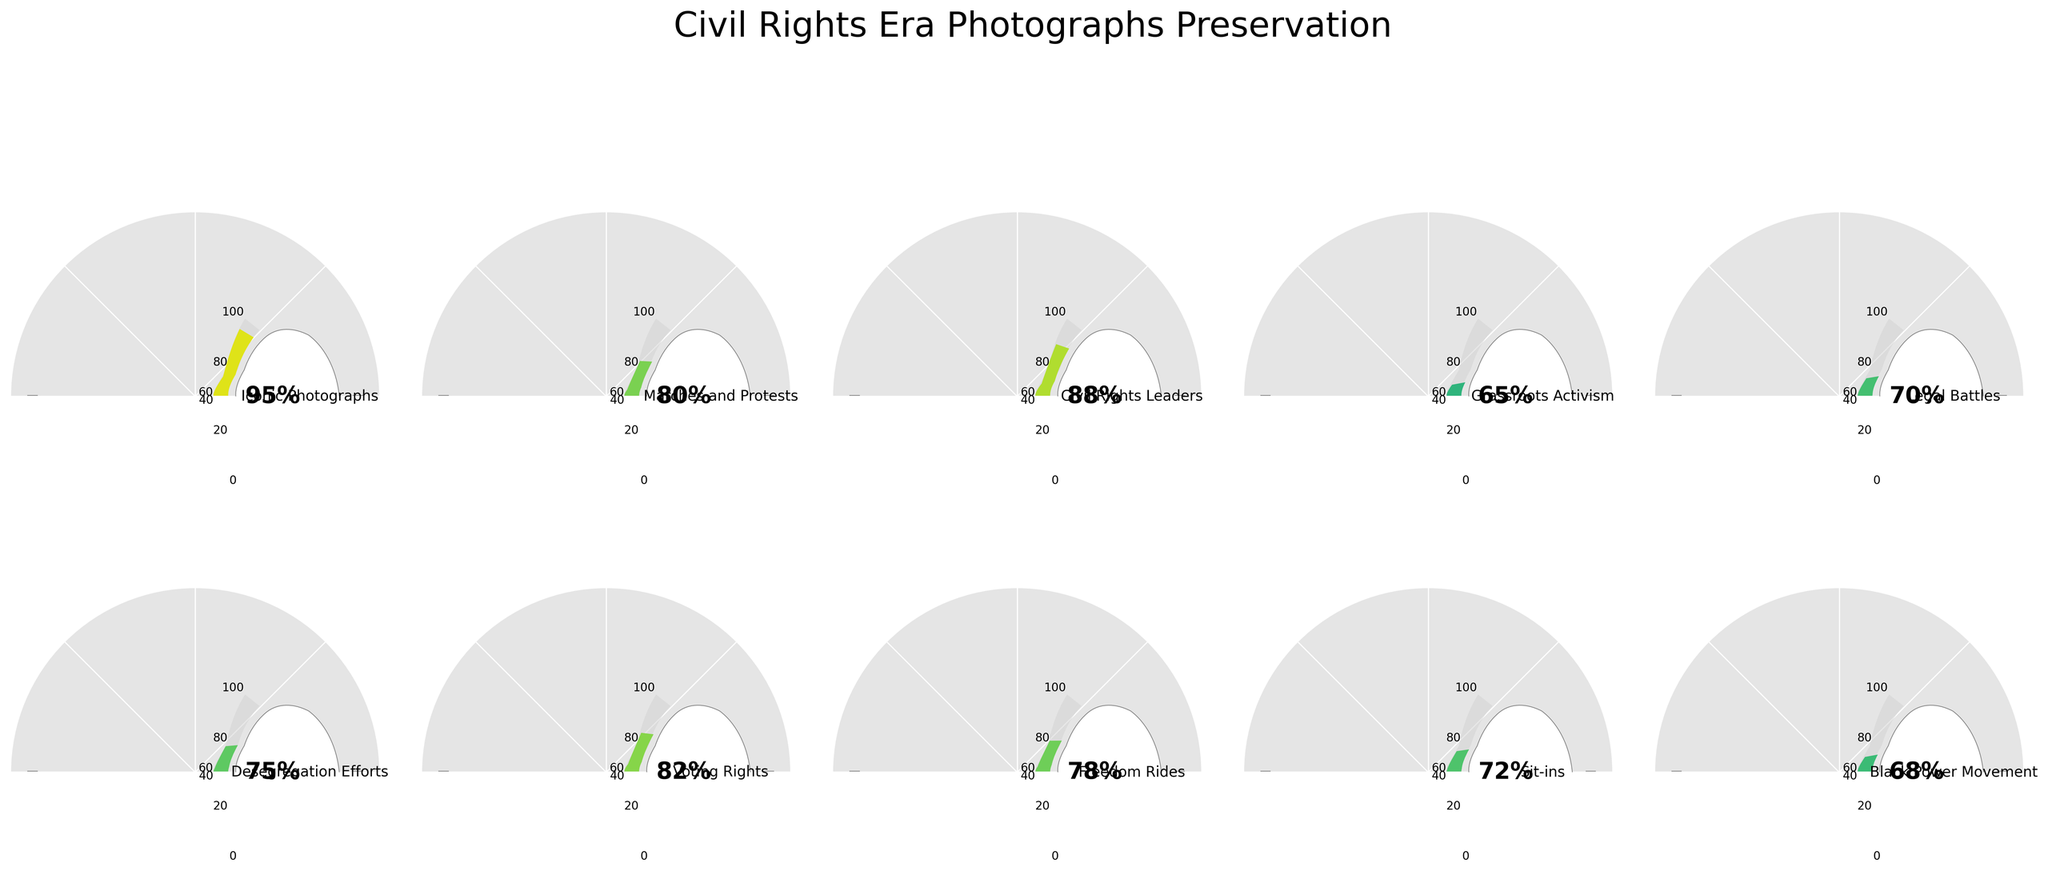What's the title of the figure? The title is placed at the top center of the figure, providing an overview of what the chart is depicting.
Answer: Civil Rights Era Photographs Preservation Which category has the highest percentage of preserved photographs? To find the category with the highest percentage, look at each gauge chart and identify the one with the largest percentage value.
Answer: Iconic Photographs Which category shows the smallest percentage of preserved photographs? To determine the smallest percentage, review all categories and select the one with the lowest percentage.
Answer: Grassroots Activism What is the average percentage of preserved photographs across all categories? To find the average, sum all the percentages and divide by the number of categories. (95+80+88+65+70+75+82+78+72+68) / 10 = 77.3
Answer: 77.3% How many categories have a preservation percentage equal to or greater than 80%? Count the number of categories where the preservation percentage is 80% or higher. The qualified categories are "Iconic Photographs", "Marches and Protests", "Civil Rights Leaders", "Voting Rights".
Answer: 4 Which categories have more than 80% preservation but less than 90% preservation? Identify all categories where the preservation percentage falls within the specified range (80 < percentage < 90). These categories are "Civil Rights Leaders" (88%) and "Voting Rights" (82%).
Answer: Civil Rights Leaders, Voting Rights How does the preservation percentage of "Sit-ins" compare to "Freedom Rides"? Compare "Sit-ins" (72%) with "Freedom Rides" (78%). Since 72% is less than 78%, "Sit-ins" have a lower preservation percentage.
Answer: Sit-ins < Freedom Rides What is the total preservation percentage of the categories "Desegregation Efforts" and "Legal Battles"? Add the preservation percentages of "Desegregation Efforts" (75%) and "Legal Battles" (70%) to get the total. 75 + 70 = 145
Answer: 145 What can you infer about the preservation efforts for "Voting Rights" compared to "Sit-ins"? Compare the percentages: "Voting Rights" (82%) is significantly higher than "Sit-ins" (72%). This indicates that preservation efforts for "Voting Rights" are stronger.
Answer: Voting Rights > Sit-ins Is the preservation percentage of "Grassroots Activism" above or below the average? The preservation percentage of "Grassroots Activism" is 65%, which is below the computed average of 77.3%.
Answer: Below 